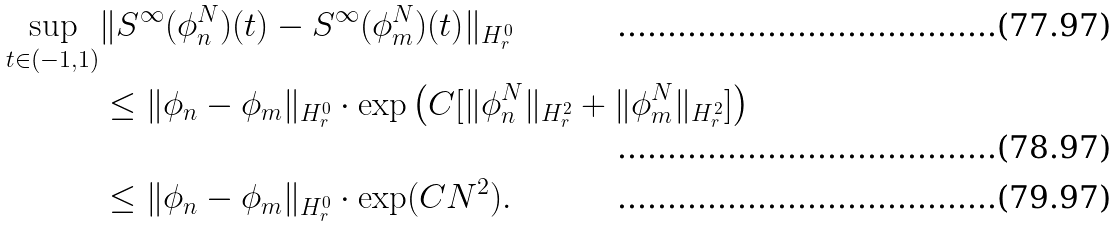<formula> <loc_0><loc_0><loc_500><loc_500>\sup _ { t \in ( - 1 , 1 ) } & \| S ^ { \infty } ( \phi _ { n } ^ { N } ) ( t ) - S ^ { \infty } ( \phi _ { m } ^ { N } ) ( t ) \| _ { H ^ { 0 } _ { r } } \\ & \leq \| \phi _ { n } - \phi _ { m } \| _ { H ^ { 0 } _ { r } } \cdot \exp \left ( C [ \| \phi _ { n } ^ { N } \| _ { H ^ { 2 } _ { r } } + \| \phi _ { m } ^ { N } \| _ { H ^ { 2 } _ { r } } ] \right ) \\ & \leq \| \phi _ { n } - \phi _ { m } \| _ { H ^ { 0 } _ { r } } \cdot \exp ( C N ^ { 2 } ) .</formula> 